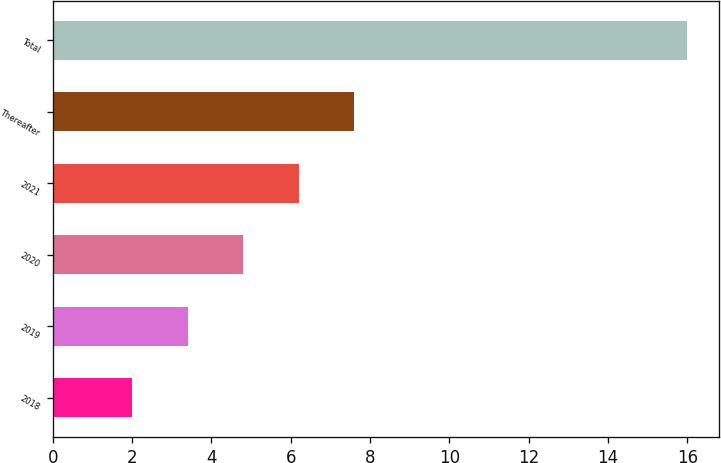Convert chart. <chart><loc_0><loc_0><loc_500><loc_500><bar_chart><fcel>2018<fcel>2019<fcel>2020<fcel>2021<fcel>Thereafter<fcel>Total<nl><fcel>2<fcel>3.4<fcel>4.8<fcel>6.2<fcel>7.6<fcel>16<nl></chart> 